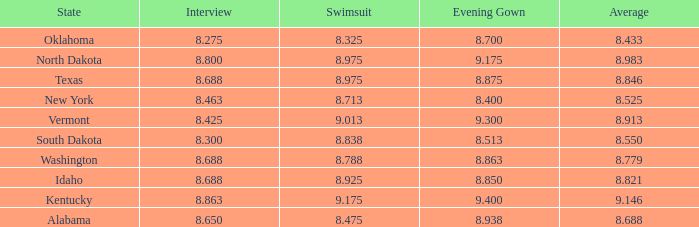What is the average interview score from Kentucky? 8.863. 